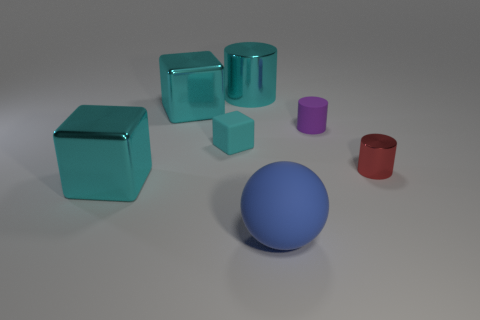Are there any spherical objects, and if so, what color are they? Yes, there is one spherical object in the center of the image, and it has a vibrant blue color. It stands out due to its unique shape among the other geometric figures. Could that blue sphere fit inside any of the containers shown? It appears that the blue sphere might fit into the large cyan cylinder on the left side. The cylinder seems to be the largest container in the image with a wide-open top that could potentially accommodate the sphere. 